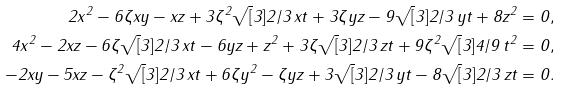Convert formula to latex. <formula><loc_0><loc_0><loc_500><loc_500>2 x ^ { 2 } - 6 \zeta x y - x z + 3 \zeta ^ { 2 } \sqrt { [ } 3 ] { 2 / 3 } \, x t + 3 \zeta y z - 9 \sqrt { [ } 3 ] { 2 / 3 } \, y t + 8 z ^ { 2 } = 0 , \\ 4 x ^ { 2 } - 2 x z - 6 \zeta \sqrt { [ } 3 ] { 2 / 3 } \, x t - 6 y z + z ^ { 2 } + 3 \zeta \sqrt { [ } 3 ] { 2 / 3 } \, z t + 9 \zeta ^ { 2 } \sqrt { [ } 3 ] { 4 / 9 } \, t ^ { 2 } = 0 , \\ - 2 x y - 5 x z - \zeta ^ { 2 } \sqrt { [ } 3 ] { 2 / 3 } \, x t + 6 \zeta y ^ { 2 } - \zeta y z + 3 \sqrt { [ } 3 ] { 2 / 3 } \, y t - 8 \sqrt { [ } 3 ] { 2 / 3 } \, z t = 0 .</formula> 